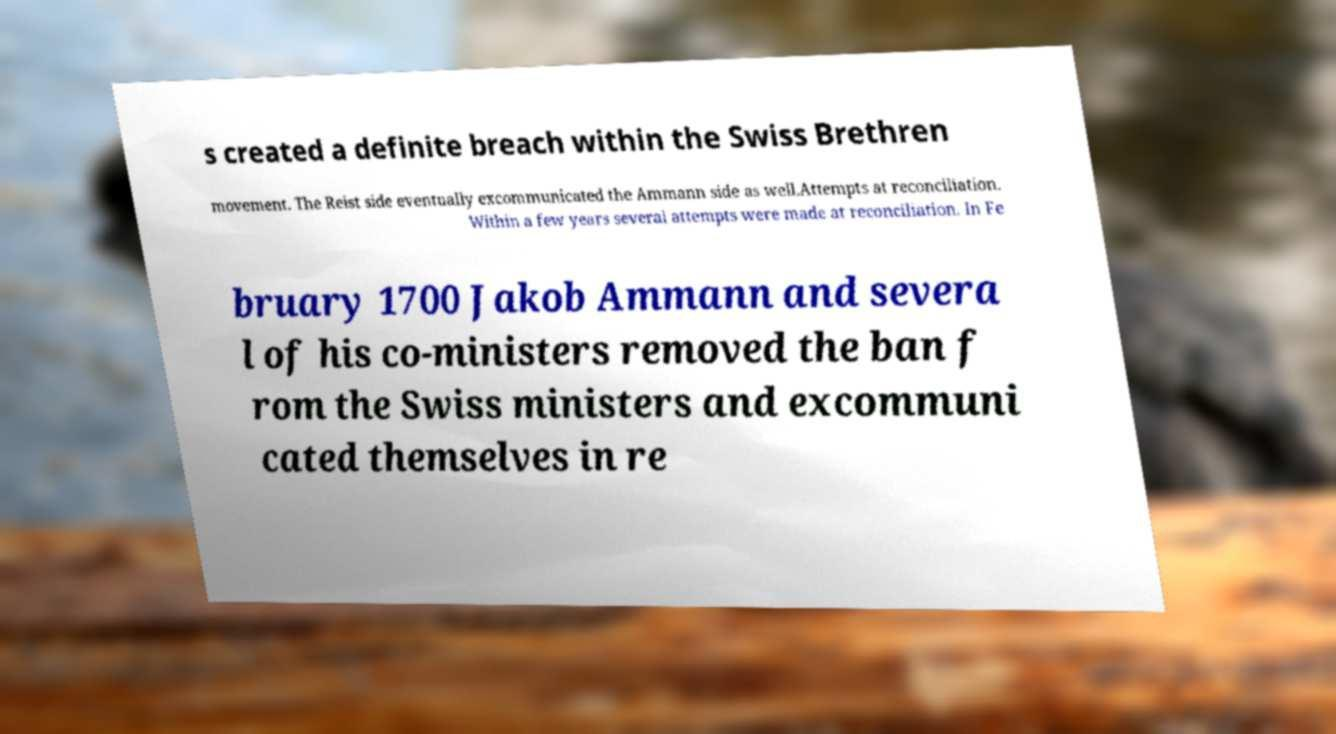What messages or text are displayed in this image? I need them in a readable, typed format. s created a definite breach within the Swiss Brethren movement. The Reist side eventually excommunicated the Ammann side as well.Attempts at reconciliation. Within a few years several attempts were made at reconciliation. In Fe bruary 1700 Jakob Ammann and severa l of his co-ministers removed the ban f rom the Swiss ministers and excommuni cated themselves in re 